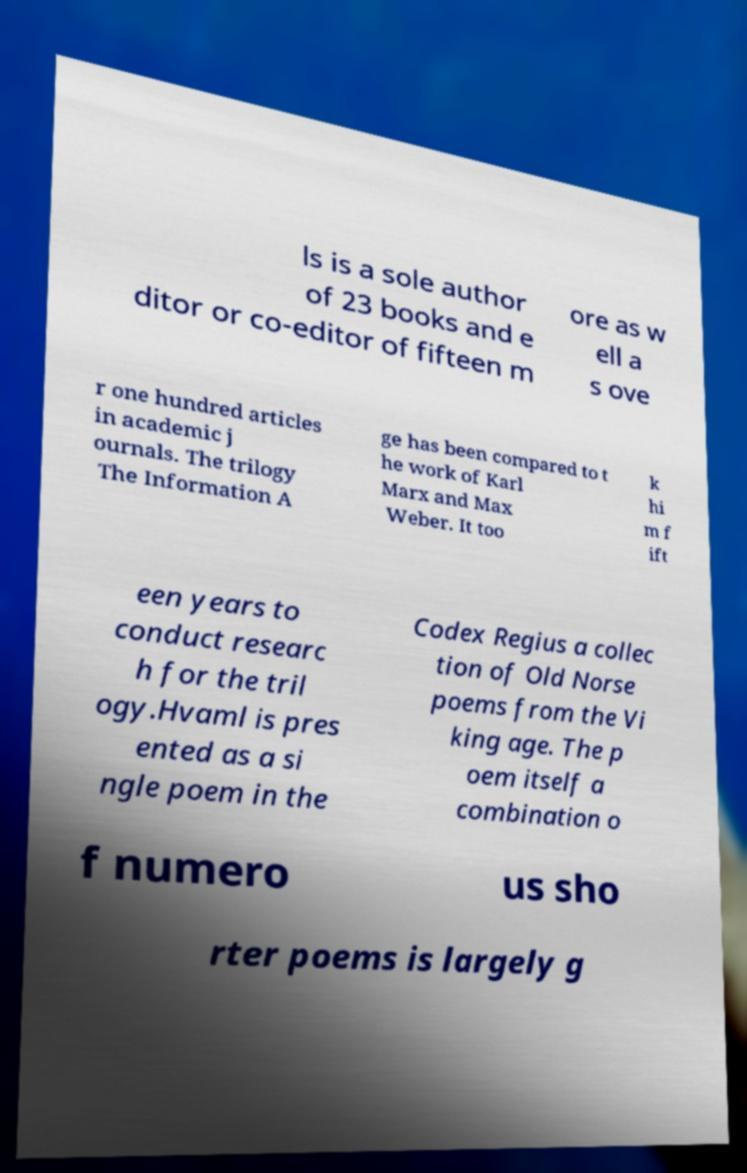Can you accurately transcribe the text from the provided image for me? ls is a sole author of 23 books and e ditor or co-editor of fifteen m ore as w ell a s ove r one hundred articles in academic j ournals. The trilogy The Information A ge has been compared to t he work of Karl Marx and Max Weber. It too k hi m f ift een years to conduct researc h for the tril ogy.Hvaml is pres ented as a si ngle poem in the Codex Regius a collec tion of Old Norse poems from the Vi king age. The p oem itself a combination o f numero us sho rter poems is largely g 